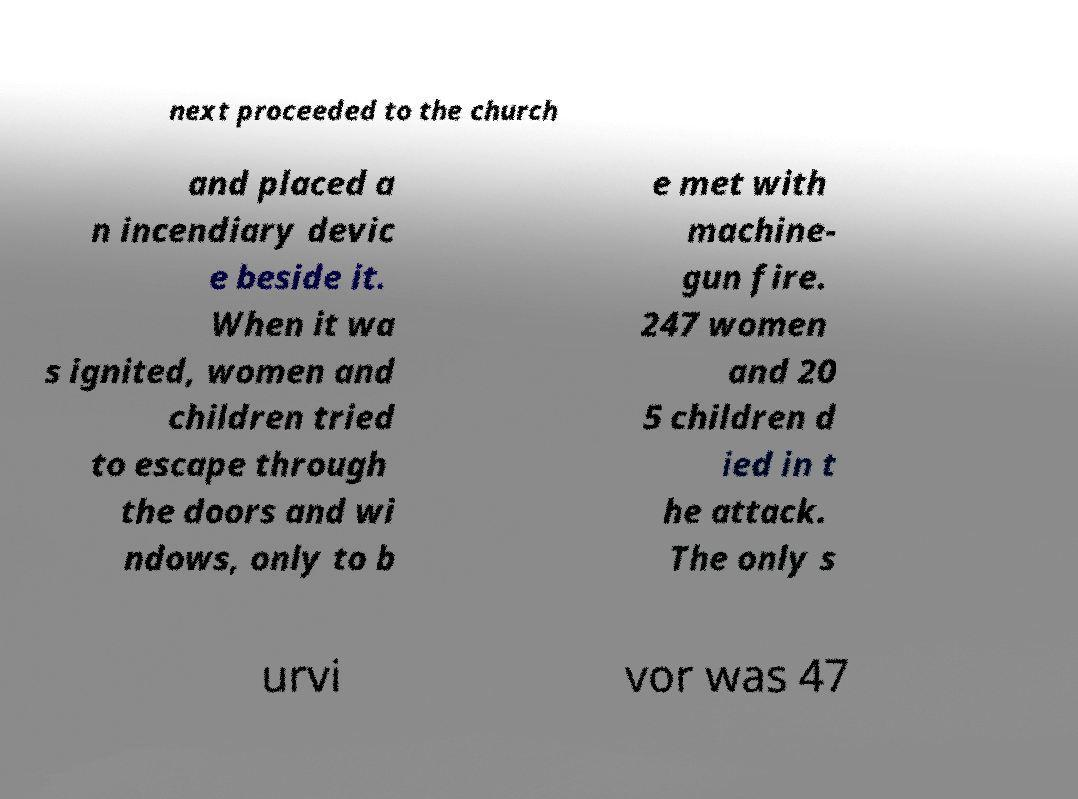Could you extract and type out the text from this image? next proceeded to the church and placed a n incendiary devic e beside it. When it wa s ignited, women and children tried to escape through the doors and wi ndows, only to b e met with machine- gun fire. 247 women and 20 5 children d ied in t he attack. The only s urvi vor was 47 